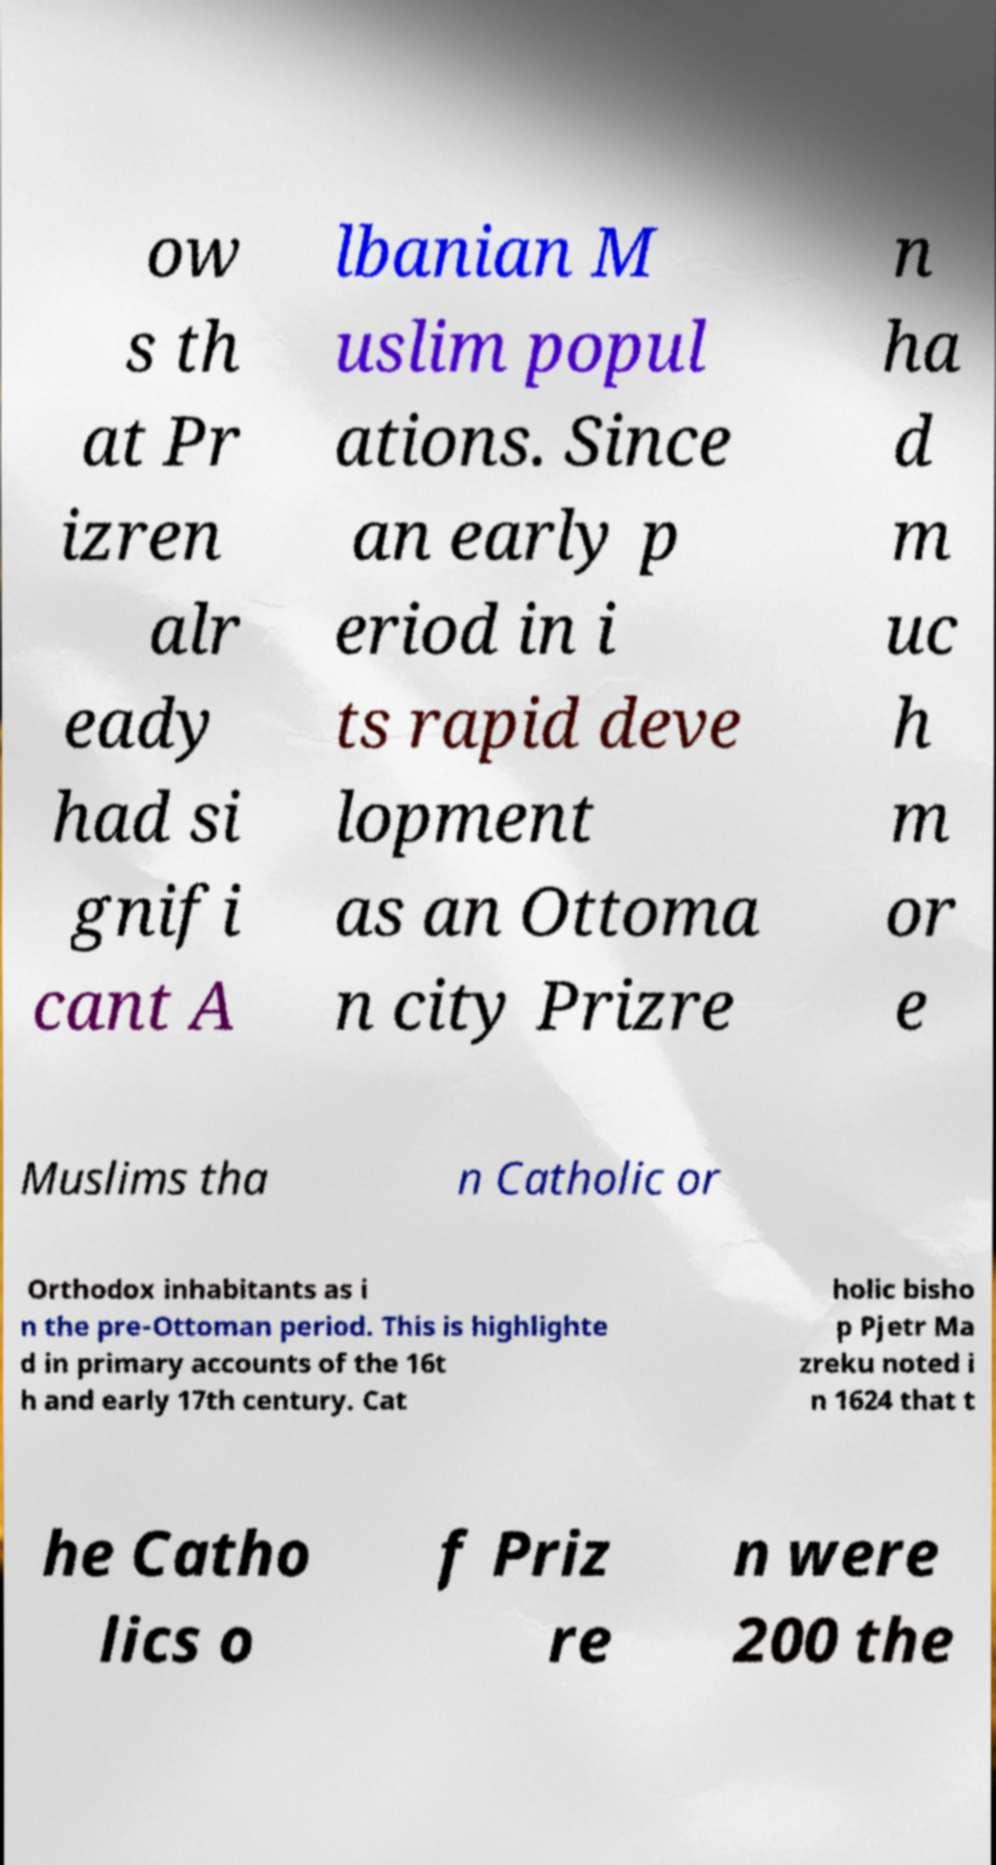I need the written content from this picture converted into text. Can you do that? ow s th at Pr izren alr eady had si gnifi cant A lbanian M uslim popul ations. Since an early p eriod in i ts rapid deve lopment as an Ottoma n city Prizre n ha d m uc h m or e Muslims tha n Catholic or Orthodox inhabitants as i n the pre-Ottoman period. This is highlighte d in primary accounts of the 16t h and early 17th century. Cat holic bisho p Pjetr Ma zreku noted i n 1624 that t he Catho lics o f Priz re n were 200 the 